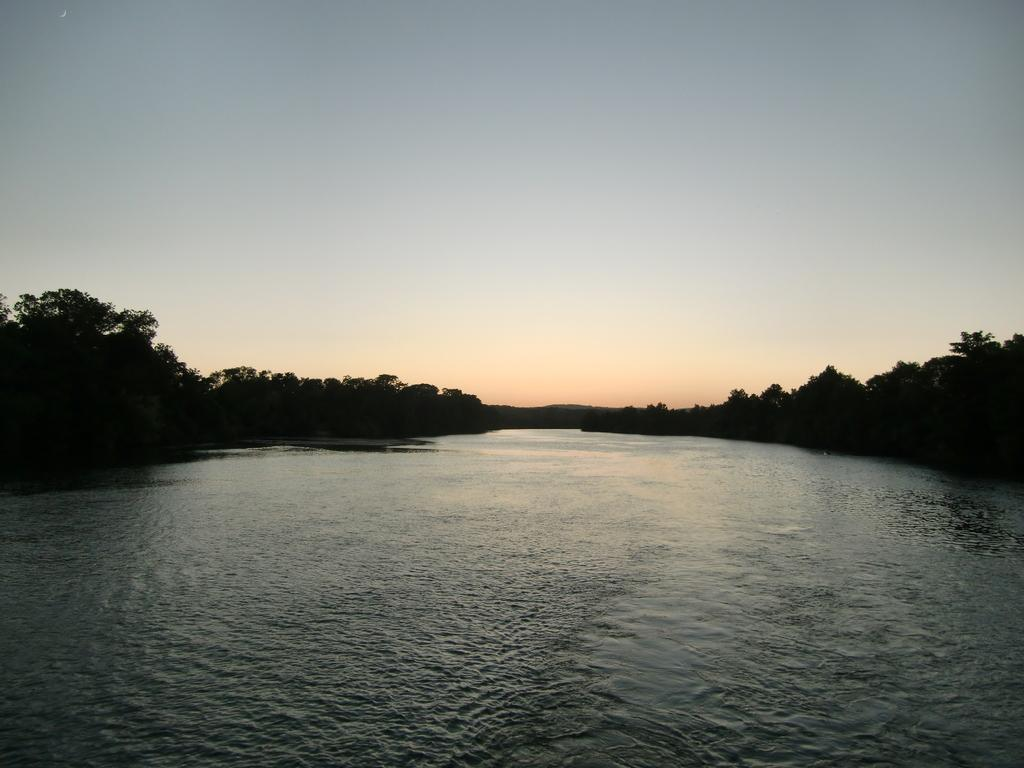What is the primary element visible in the image? There is water in the image. What type of vegetation can be seen in the image? There are trees in the image. What part of the natural environment is visible in the image? The sky is visible in the image. What date is marked on the calendar in the image? There is no calendar present in the image. Can you describe the mist in the image? There is no mist present in the image. 